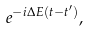<formula> <loc_0><loc_0><loc_500><loc_500>e ^ { - i \Delta E ( t - t ^ { \prime } ) } ,</formula> 